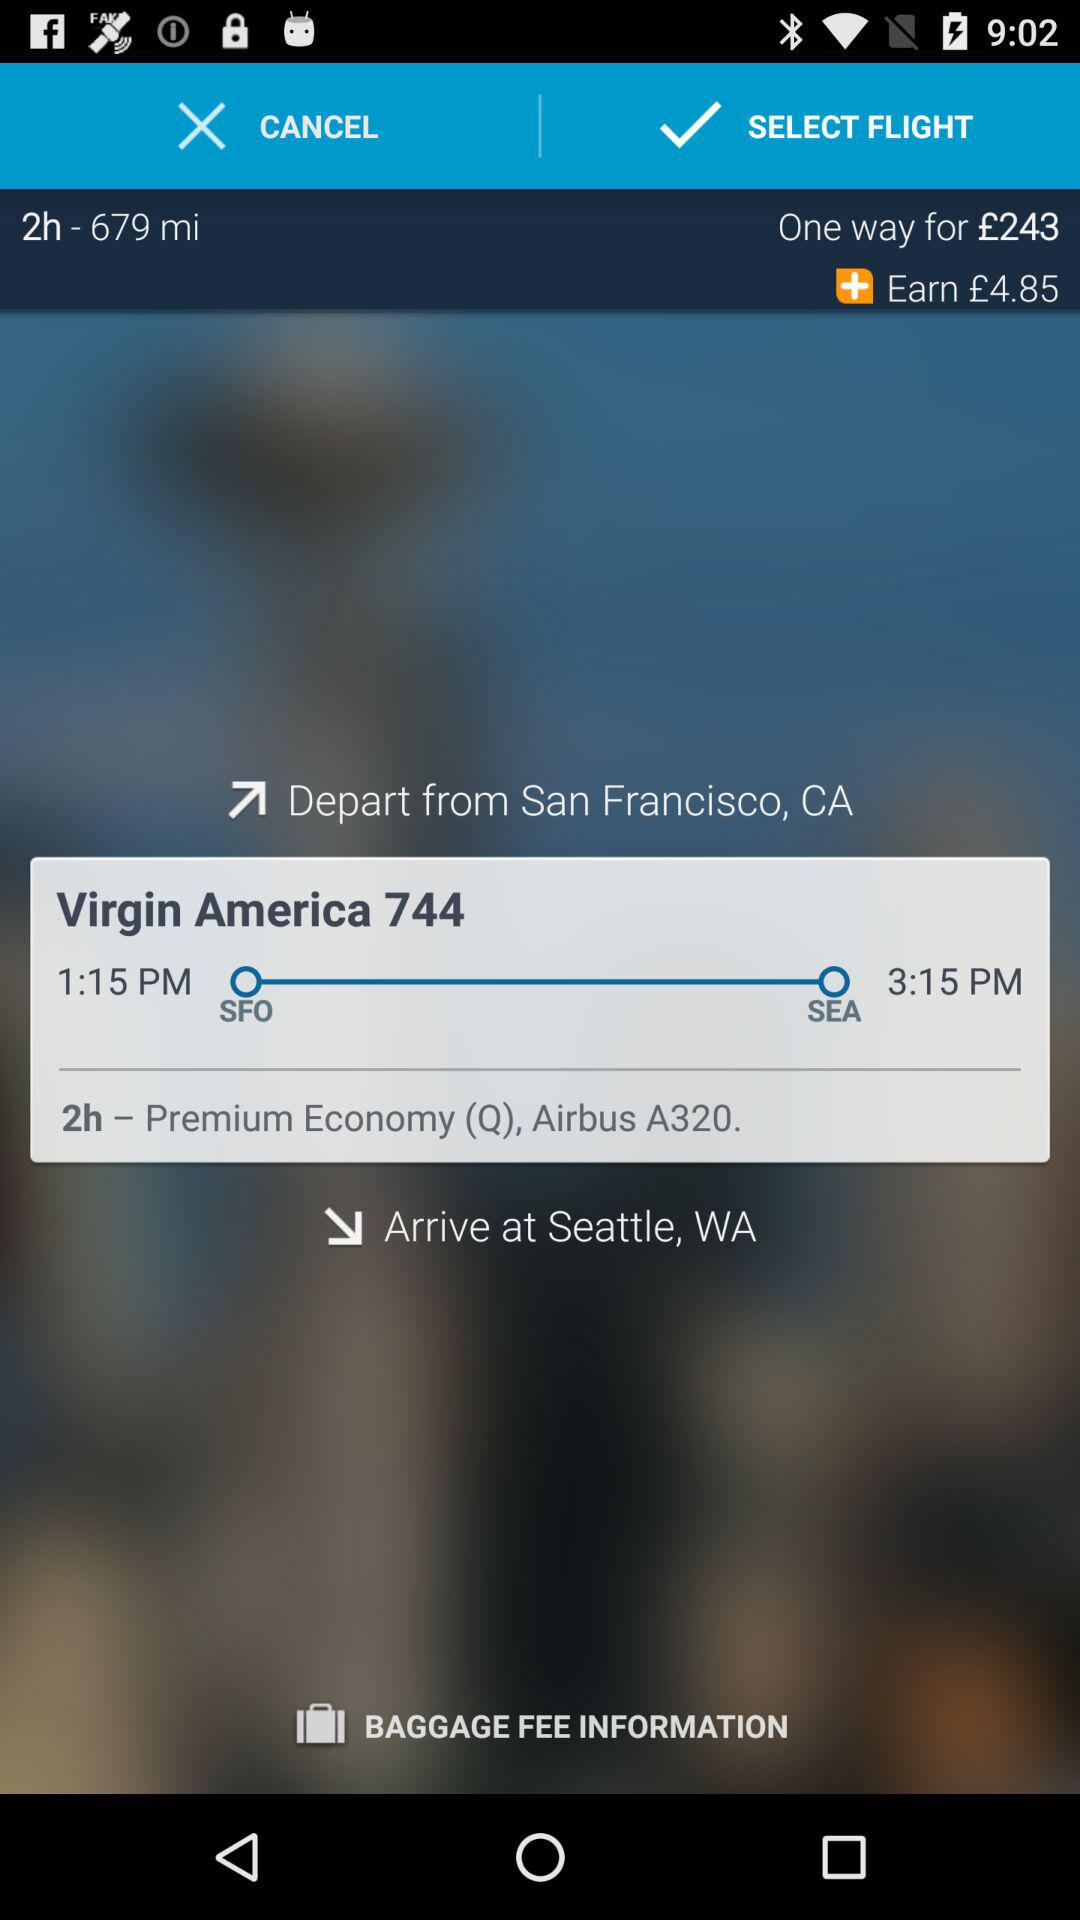What is the departure time of the flight? The departure time of the flight is 1:15 PM. 